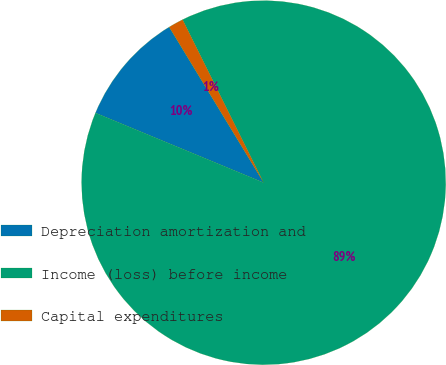Convert chart. <chart><loc_0><loc_0><loc_500><loc_500><pie_chart><fcel>Depreciation amortization and<fcel>Income (loss) before income<fcel>Capital expenditures<nl><fcel>10.06%<fcel>88.6%<fcel>1.34%<nl></chart> 